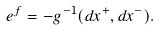Convert formula to latex. <formula><loc_0><loc_0><loc_500><loc_500>e ^ { f } = - g ^ { - 1 } ( d x ^ { + } , d x ^ { - } ) .</formula> 